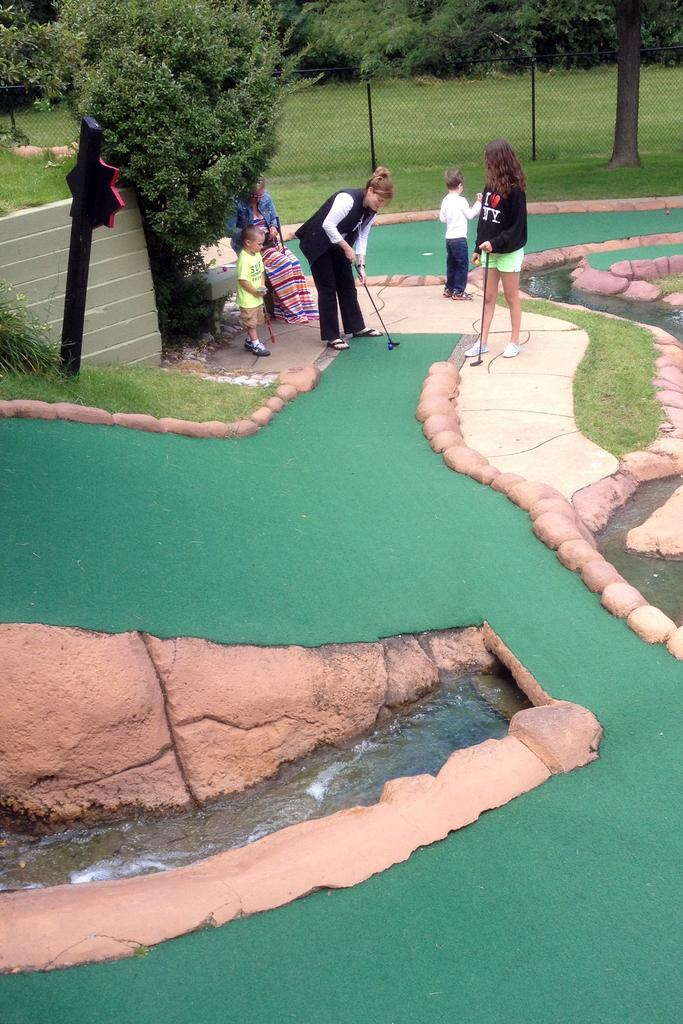How many people are in the image? There are people in the image, but the exact number is not specified. What are some people holding in the image? Some people are holding sticks in the image. What can be seen in the background of the image? There are trees in the background of the image. What type of material is visible in the image? There is a mesh visible in the image. What object can be seen in the image? There is a board in the image. What is at the bottom of the image? There is water and ground at the bottom of the image. Can you tell me how many rabbits are visible in the image? There are no rabbits present in the image. What type of bit is being used by the people in the image? There is no mention of any bit being used by the people in the image. 